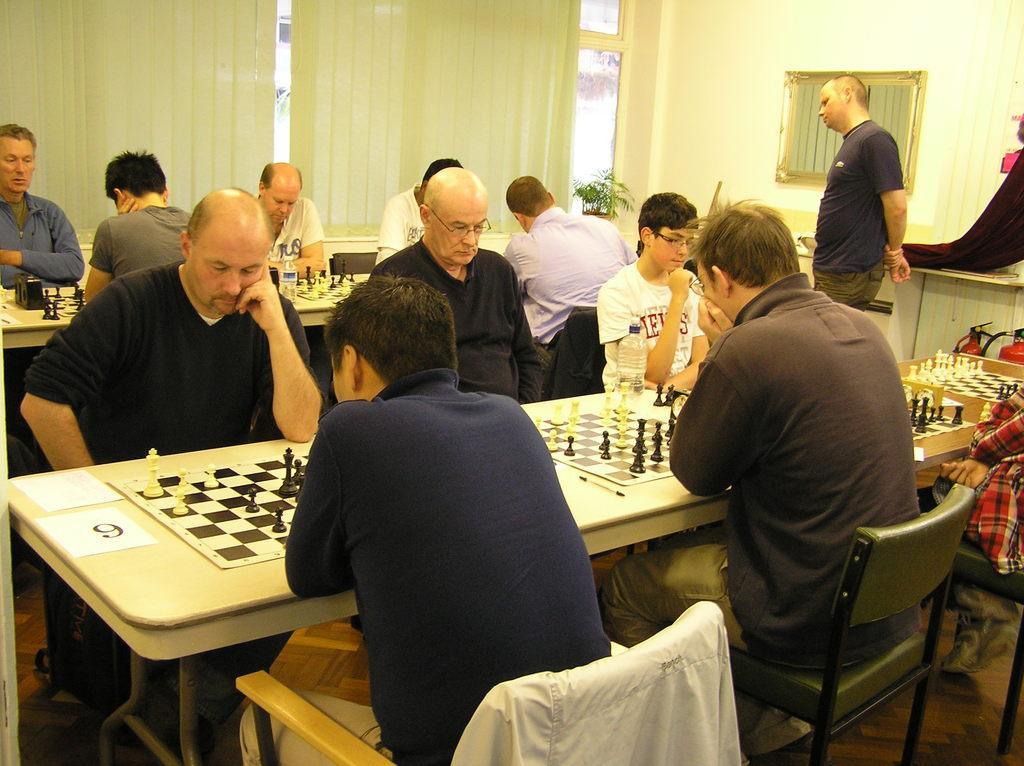What are the people in the image doing? The people in the image are playing chess on a table. How are the people positioned in the image? The people are seated on chairs. What can be seen on the wall in the image? There is a mirror on the wall. Is there anyone else in the image besides the people playing chess? Yes, a man is standing and watching them. What is the result of adding the numbers 5 and 7 in the image? There is no addition or numbers present in the image; it features a group of people playing chess. 